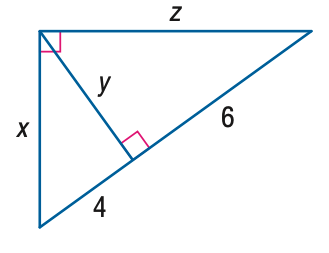Answer the mathemtical geometry problem and directly provide the correct option letter.
Question: Find z.
Choices: A: 2 \sqrt { 5 } B: 2 \sqrt { 6 } C: 2 \sqrt { 10 } D: 2 \sqrt { 15 } D 